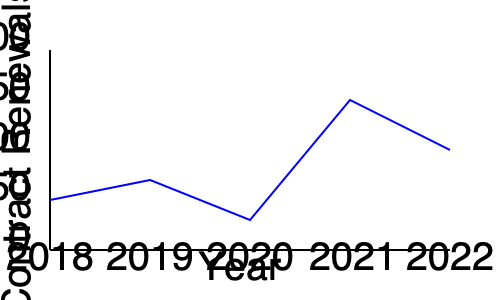Based on the line graph showing contract renewal trends from 2018 to 2022, in which year did the company experience the highest number of contract renewals? To determine the year with the highest number of contract renewals, we need to follow these steps:

1. Examine the y-axis, which represents the number of contract renewals.
2. Look at the line graph and identify the highest point on the line.
3. Trace this point to the corresponding year on the x-axis.

Analyzing the graph:
- In 2018, the renewals start at a moderate level.
- There's a slight decrease in 2019.
- 2020 shows an increase from 2019, but not the highest point.
- In 2021, we see a sharp increase, reaching the highest point on the graph.
- 2022 shows a decrease from 2021, but still higher than the 2018-2020 period.

The highest point on the graph corresponds to the year 2021, indicating that this was the year with the most contract renewals.
Answer: 2021 